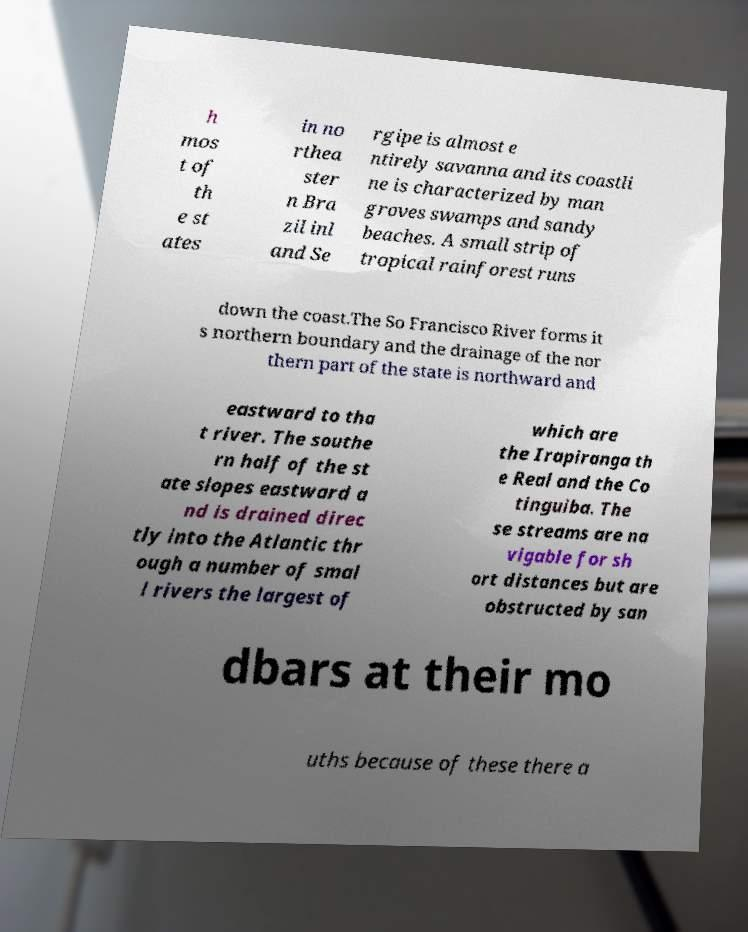Could you extract and type out the text from this image? h mos t of th e st ates in no rthea ster n Bra zil inl and Se rgipe is almost e ntirely savanna and its coastli ne is characterized by man groves swamps and sandy beaches. A small strip of tropical rainforest runs down the coast.The So Francisco River forms it s northern boundary and the drainage of the nor thern part of the state is northward and eastward to tha t river. The southe rn half of the st ate slopes eastward a nd is drained direc tly into the Atlantic thr ough a number of smal l rivers the largest of which are the Irapiranga th e Real and the Co tinguiba. The se streams are na vigable for sh ort distances but are obstructed by san dbars at their mo uths because of these there a 